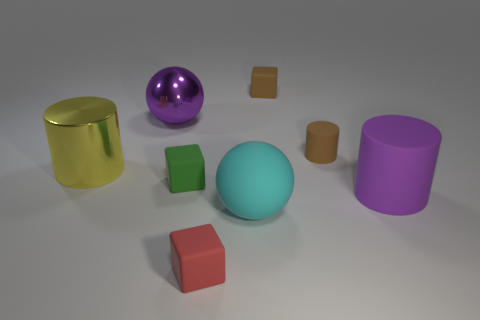There is a red thing that is the same shape as the green thing; what material is it?
Give a very brief answer. Rubber. There is a small brown object that is to the right of the tiny brown block; what number of brown matte cylinders are left of it?
Provide a short and direct response. 0. Is there anything else that is the same color as the tiny rubber cylinder?
Offer a terse response. Yes. How many things are purple cylinders or tiny things in front of the big metal cylinder?
Make the answer very short. 3. What material is the brown object behind the purple thing on the left side of the big purple object in front of the large yellow cylinder?
Your response must be concise. Rubber. What size is the red thing that is the same material as the tiny green object?
Make the answer very short. Small. The large cylinder on the left side of the small brown object in front of the large purple ball is what color?
Offer a terse response. Yellow. What number of yellow things are made of the same material as the brown block?
Offer a terse response. 0. How many metallic objects are yellow things or tiny cylinders?
Give a very brief answer. 1. There is another purple thing that is the same size as the purple metal object; what material is it?
Give a very brief answer. Rubber. 